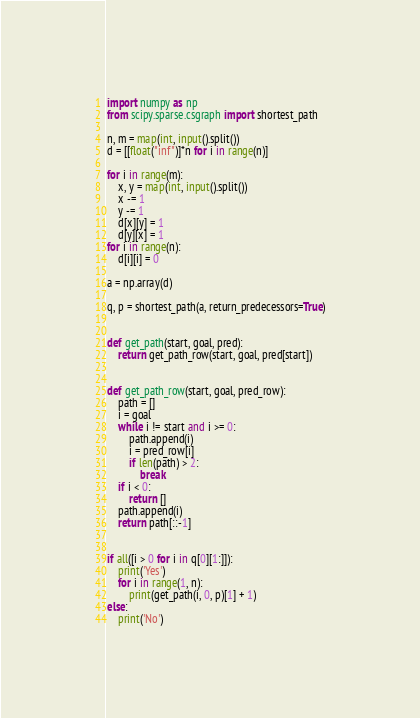<code> <loc_0><loc_0><loc_500><loc_500><_Python_>import numpy as np
from scipy.sparse.csgraph import shortest_path

n, m = map(int, input().split())
d = [[float("inf")]*n for i in range(n)]

for i in range(m):
    x, y = map(int, input().split())
    x -= 1
    y -= 1
    d[x][y] = 1
    d[y][x] = 1
for i in range(n):
    d[i][i] = 0

a = np.array(d)

q, p = shortest_path(a, return_predecessors=True)


def get_path(start, goal, pred):
    return get_path_row(start, goal, pred[start])


def get_path_row(start, goal, pred_row):
    path = []
    i = goal
    while i != start and i >= 0:
        path.append(i)
        i = pred_row[i]
        if len(path) > 2:
            break
    if i < 0:
        return []
    path.append(i)
    return path[::-1]


if all([i > 0 for i in q[0][1:]]):
    print('Yes')
    for i in range(1, n):
        print(get_path(i, 0, p)[1] + 1)
else:
    print('No')
</code> 